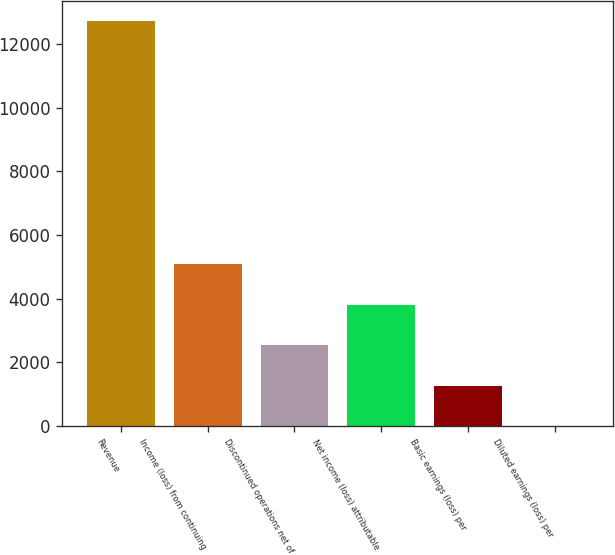Convert chart. <chart><loc_0><loc_0><loc_500><loc_500><bar_chart><fcel>Revenue<fcel>Income (loss) from continuing<fcel>Discontinued operations net of<fcel>Net income (loss) attributable<fcel>Basic earnings (loss) per<fcel>Diluted earnings (loss) per<nl><fcel>12716<fcel>5086.98<fcel>2543.98<fcel>3815.48<fcel>1272.48<fcel>0.98<nl></chart> 